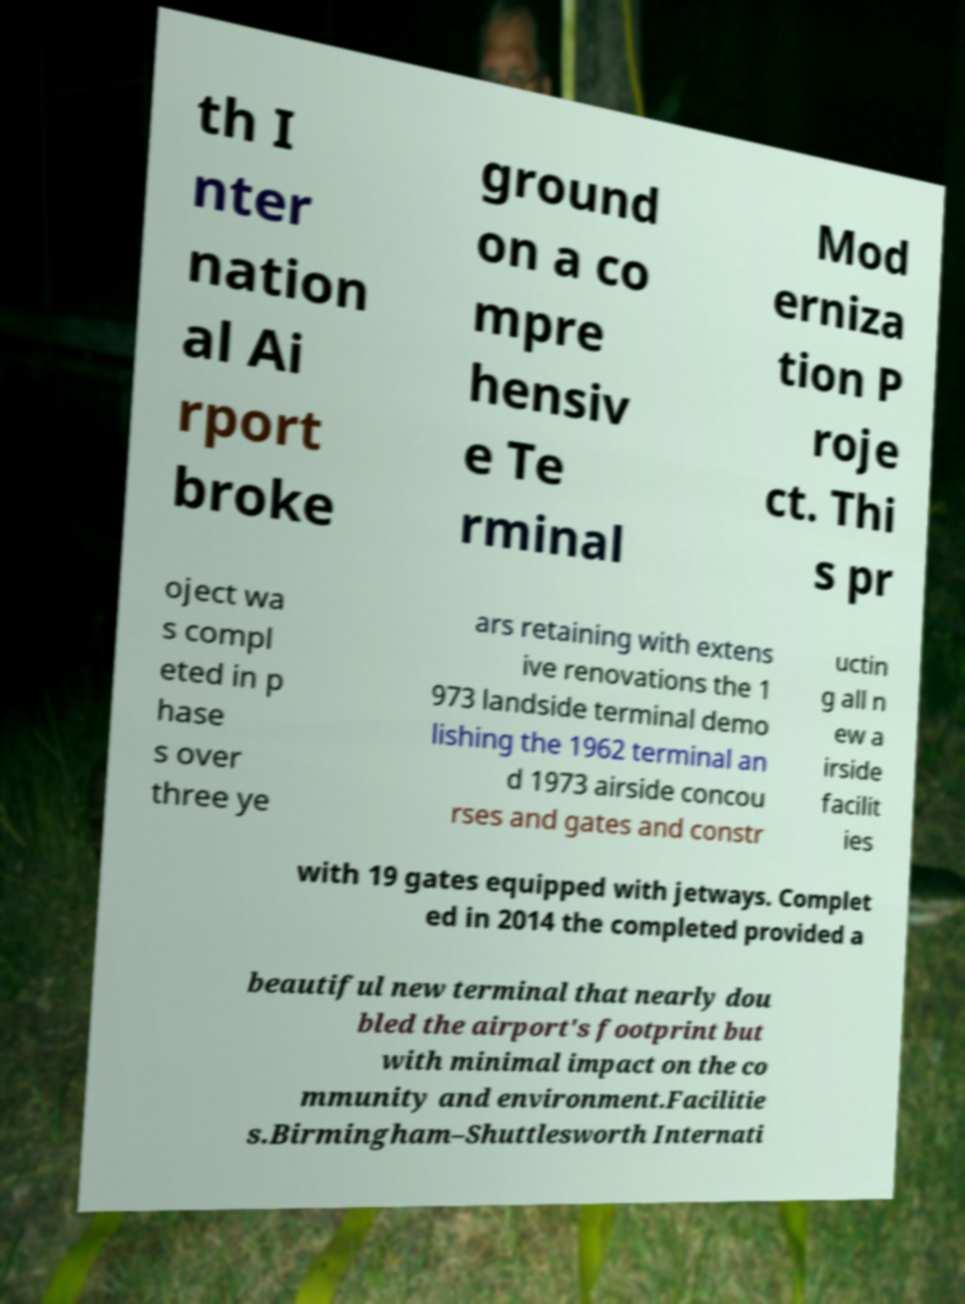What messages or text are displayed in this image? I need them in a readable, typed format. th I nter nation al Ai rport broke ground on a co mpre hensiv e Te rminal Mod erniza tion P roje ct. Thi s pr oject wa s compl eted in p hase s over three ye ars retaining with extens ive renovations the 1 973 landside terminal demo lishing the 1962 terminal an d 1973 airside concou rses and gates and constr uctin g all n ew a irside facilit ies with 19 gates equipped with jetways. Complet ed in 2014 the completed provided a beautiful new terminal that nearly dou bled the airport's footprint but with minimal impact on the co mmunity and environment.Facilitie s.Birmingham–Shuttlesworth Internati 